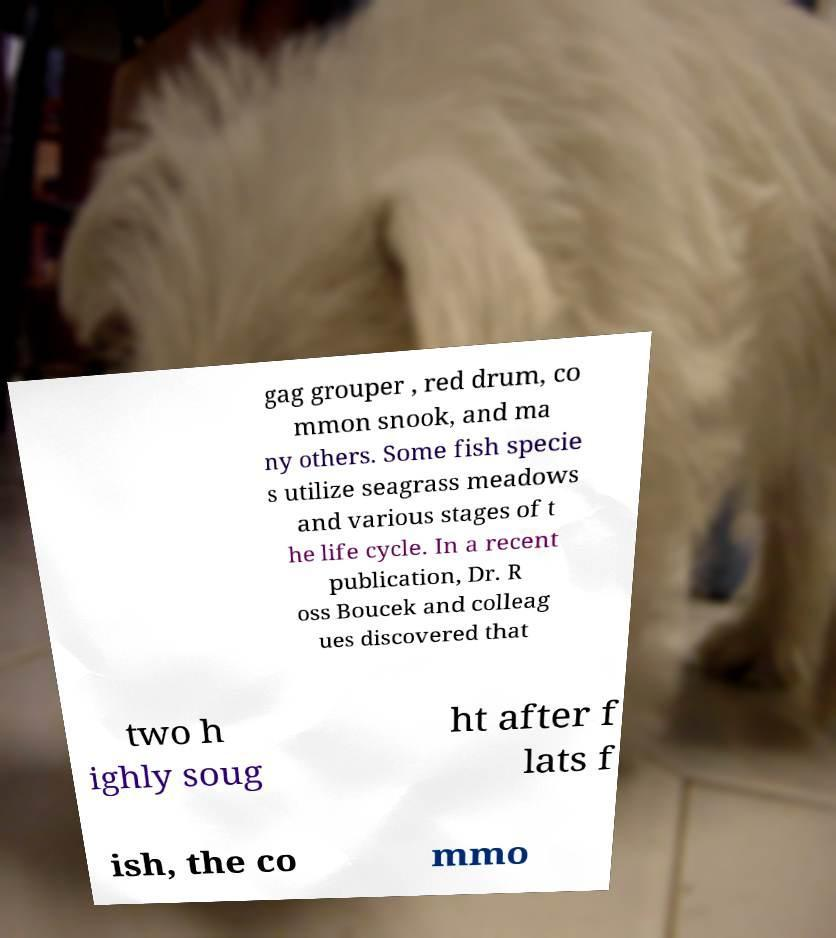Please identify and transcribe the text found in this image. gag grouper , red drum, co mmon snook, and ma ny others. Some fish specie s utilize seagrass meadows and various stages of t he life cycle. In a recent publication, Dr. R oss Boucek and colleag ues discovered that two h ighly soug ht after f lats f ish, the co mmo 